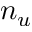Convert formula to latex. <formula><loc_0><loc_0><loc_500><loc_500>n _ { u }</formula> 